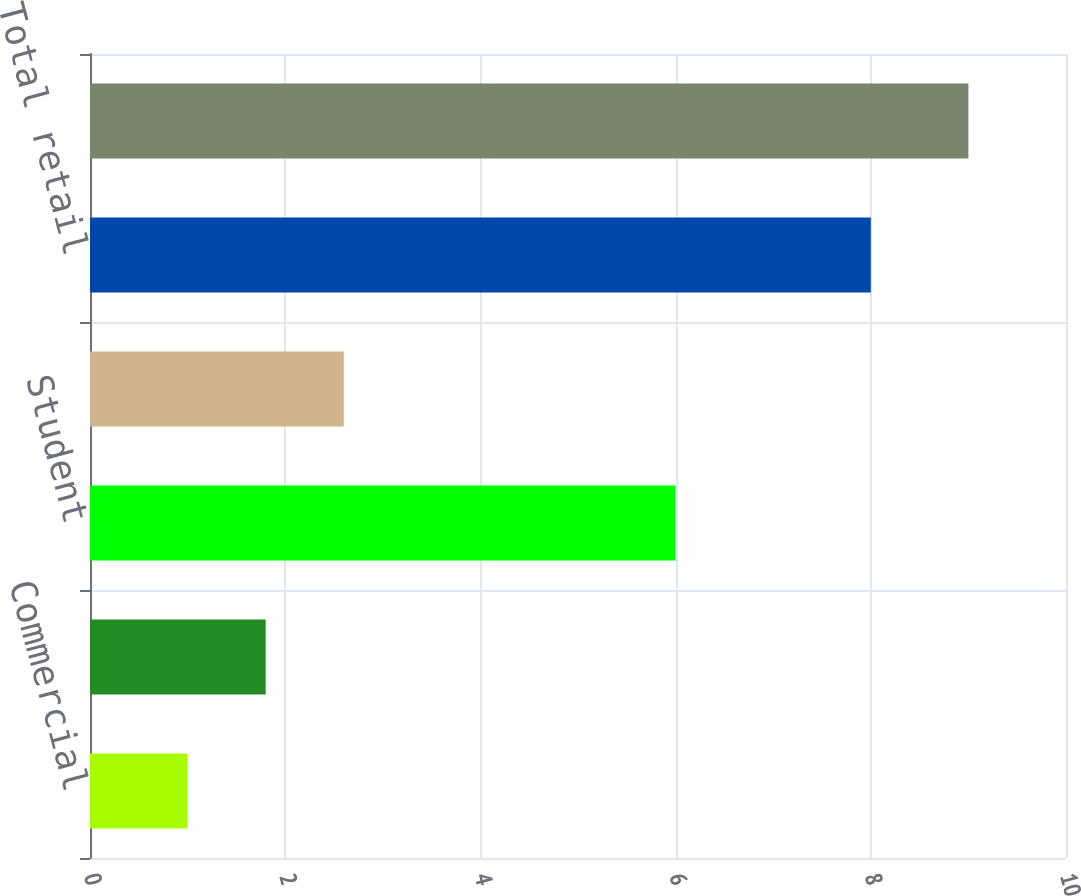Convert chart to OTSL. <chart><loc_0><loc_0><loc_500><loc_500><bar_chart><fcel>Commercial<fcel>Total commercial<fcel>Student<fcel>Other retail<fcel>Total retail<fcel>Total<nl><fcel>1<fcel>1.8<fcel>6<fcel>2.6<fcel>8<fcel>9<nl></chart> 